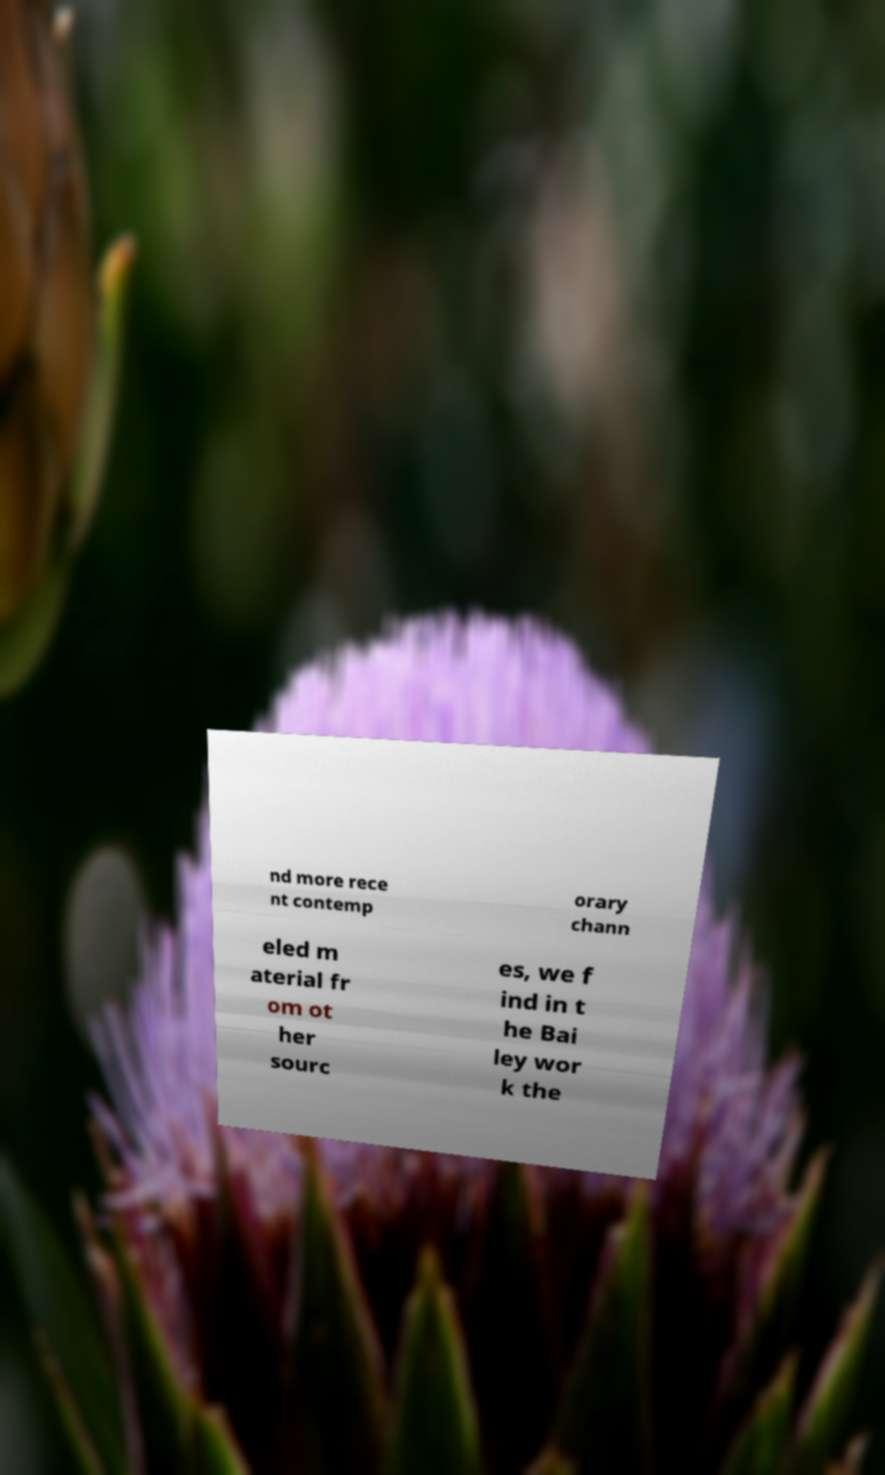Please read and relay the text visible in this image. What does it say? nd more rece nt contemp orary chann eled m aterial fr om ot her sourc es, we f ind in t he Bai ley wor k the 